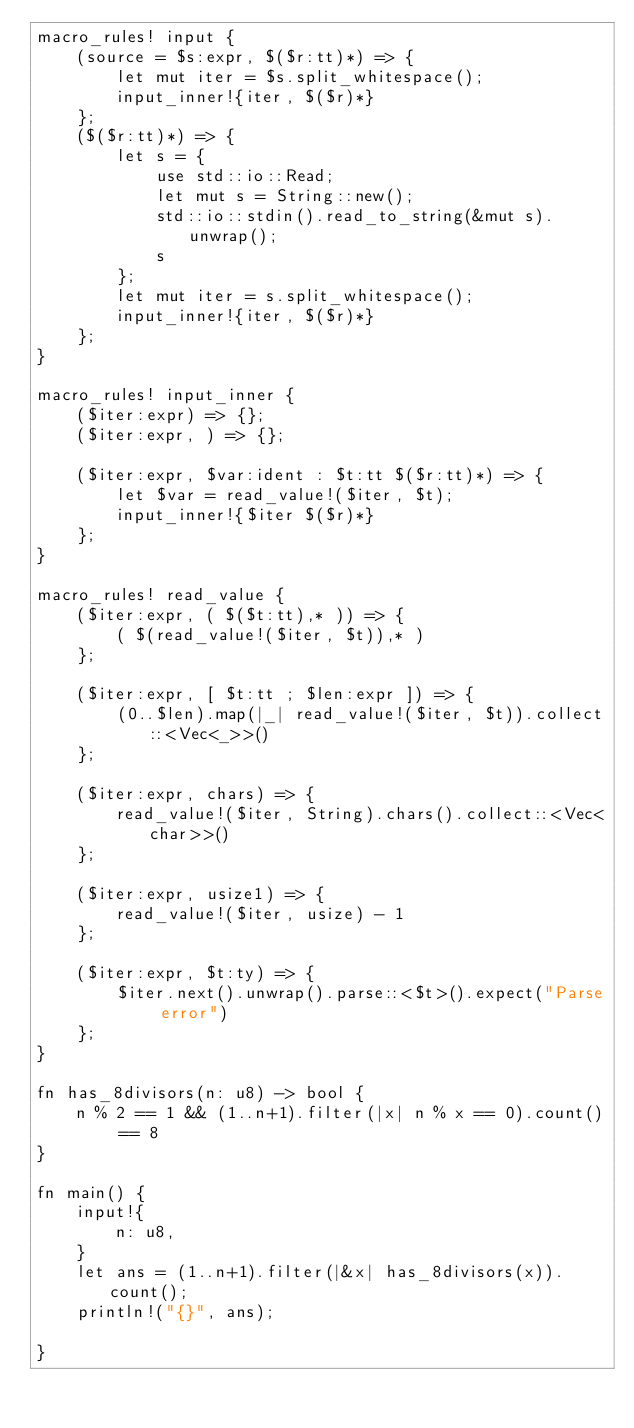<code> <loc_0><loc_0><loc_500><loc_500><_Rust_>macro_rules! input {
    (source = $s:expr, $($r:tt)*) => {
        let mut iter = $s.split_whitespace();
        input_inner!{iter, $($r)*}
    };
    ($($r:tt)*) => {
        let s = {
            use std::io::Read;
            let mut s = String::new();
            std::io::stdin().read_to_string(&mut s).unwrap();
            s
        };
        let mut iter = s.split_whitespace();
        input_inner!{iter, $($r)*}
    };
}

macro_rules! input_inner {
    ($iter:expr) => {};
    ($iter:expr, ) => {};

    ($iter:expr, $var:ident : $t:tt $($r:tt)*) => {
        let $var = read_value!($iter, $t);
        input_inner!{$iter $($r)*}
    };
}

macro_rules! read_value {
    ($iter:expr, ( $($t:tt),* )) => {
        ( $(read_value!($iter, $t)),* )
    };

    ($iter:expr, [ $t:tt ; $len:expr ]) => {
        (0..$len).map(|_| read_value!($iter, $t)).collect::<Vec<_>>()
    };

    ($iter:expr, chars) => {
        read_value!($iter, String).chars().collect::<Vec<char>>()
    };

    ($iter:expr, usize1) => {
        read_value!($iter, usize) - 1
    };

    ($iter:expr, $t:ty) => {
        $iter.next().unwrap().parse::<$t>().expect("Parse error")
    };
}

fn has_8divisors(n: u8) -> bool {
    n % 2 == 1 && (1..n+1).filter(|x| n % x == 0).count() == 8
}

fn main() {
    input!{
        n: u8,
    }
    let ans = (1..n+1).filter(|&x| has_8divisors(x)).count();
    println!("{}", ans);

}
</code> 